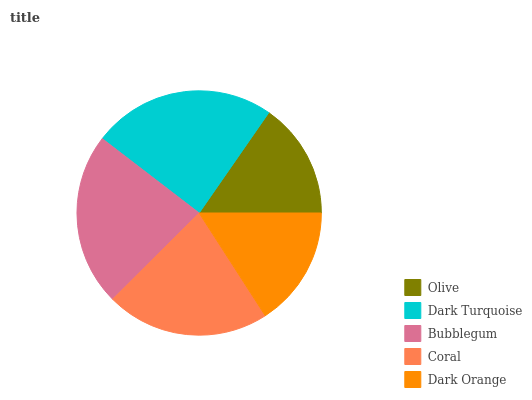Is Olive the minimum?
Answer yes or no. Yes. Is Dark Turquoise the maximum?
Answer yes or no. Yes. Is Bubblegum the minimum?
Answer yes or no. No. Is Bubblegum the maximum?
Answer yes or no. No. Is Dark Turquoise greater than Bubblegum?
Answer yes or no. Yes. Is Bubblegum less than Dark Turquoise?
Answer yes or no. Yes. Is Bubblegum greater than Dark Turquoise?
Answer yes or no. No. Is Dark Turquoise less than Bubblegum?
Answer yes or no. No. Is Coral the high median?
Answer yes or no. Yes. Is Coral the low median?
Answer yes or no. Yes. Is Bubblegum the high median?
Answer yes or no. No. Is Olive the low median?
Answer yes or no. No. 